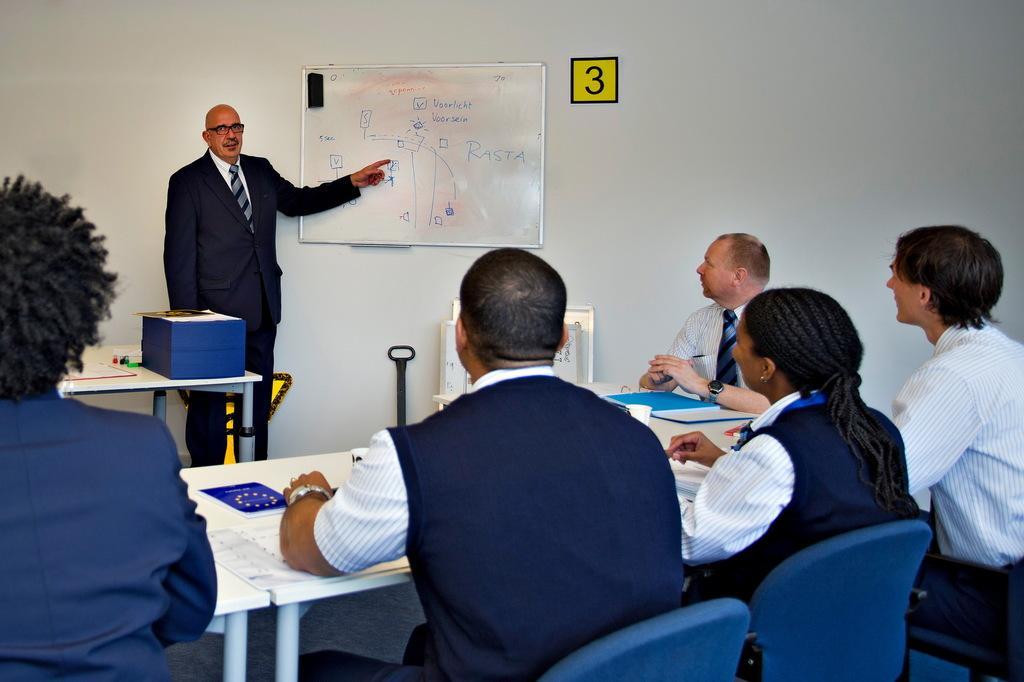How would you summarize this image in a sentence or two? The image is inside the room. In the image there are group of people sitting on chair in front of a table, on table we can see paper,book,glass and a file. On left side there is a man standing and we can also white color wall in which it is written something, in background there is a wall which is in white color. 